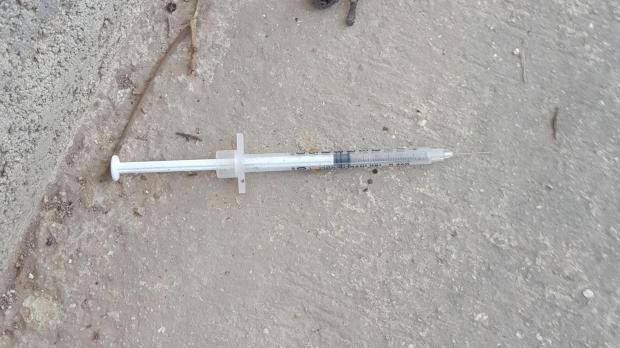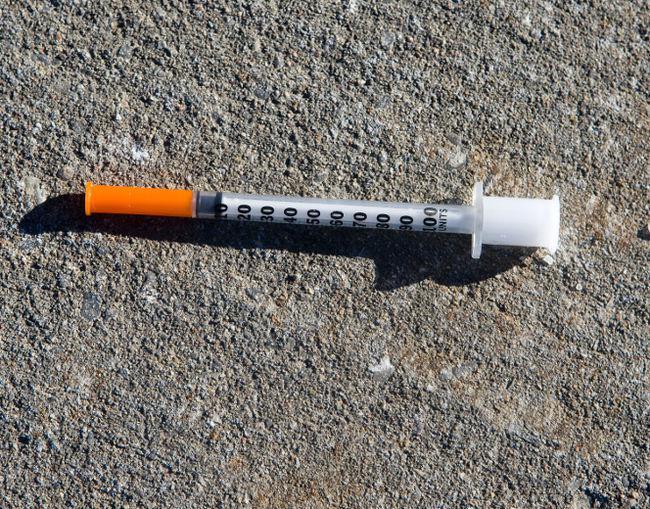The first image is the image on the left, the second image is the image on the right. For the images shown, is this caption "There are two syringes lying on the floor" true? Answer yes or no. Yes. The first image is the image on the left, the second image is the image on the right. Evaluate the accuracy of this statement regarding the images: "Each image shows one syringe, which is on a cement-type surface.". Is it true? Answer yes or no. Yes. 